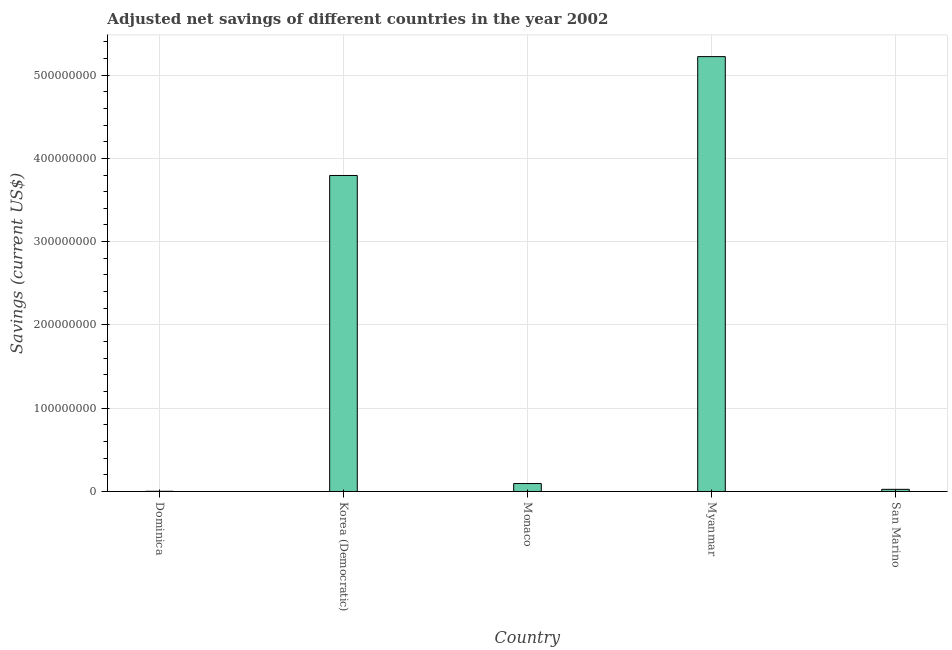What is the title of the graph?
Your answer should be compact. Adjusted net savings of different countries in the year 2002. What is the label or title of the Y-axis?
Your answer should be compact. Savings (current US$). What is the adjusted net savings in Myanmar?
Offer a terse response. 5.22e+08. Across all countries, what is the maximum adjusted net savings?
Your answer should be very brief. 5.22e+08. Across all countries, what is the minimum adjusted net savings?
Your answer should be compact. 2.14e+05. In which country was the adjusted net savings maximum?
Keep it short and to the point. Myanmar. In which country was the adjusted net savings minimum?
Offer a very short reply. Dominica. What is the sum of the adjusted net savings?
Keep it short and to the point. 9.14e+08. What is the difference between the adjusted net savings in Dominica and San Marino?
Ensure brevity in your answer.  -2.35e+06. What is the average adjusted net savings per country?
Provide a short and direct response. 1.83e+08. What is the median adjusted net savings?
Your answer should be compact. 9.52e+06. In how many countries, is the adjusted net savings greater than 360000000 US$?
Offer a very short reply. 2. What is the ratio of the adjusted net savings in Korea (Democratic) to that in Myanmar?
Give a very brief answer. 0.73. Is the difference between the adjusted net savings in Korea (Democratic) and Monaco greater than the difference between any two countries?
Give a very brief answer. No. What is the difference between the highest and the second highest adjusted net savings?
Keep it short and to the point. 1.43e+08. Is the sum of the adjusted net savings in Korea (Democratic) and Myanmar greater than the maximum adjusted net savings across all countries?
Ensure brevity in your answer.  Yes. What is the difference between the highest and the lowest adjusted net savings?
Offer a terse response. 5.22e+08. Are all the bars in the graph horizontal?
Give a very brief answer. No. How many countries are there in the graph?
Provide a short and direct response. 5. What is the Savings (current US$) of Dominica?
Offer a very short reply. 2.14e+05. What is the Savings (current US$) of Korea (Democratic)?
Give a very brief answer. 3.79e+08. What is the Savings (current US$) in Monaco?
Give a very brief answer. 9.52e+06. What is the Savings (current US$) of Myanmar?
Offer a very short reply. 5.22e+08. What is the Savings (current US$) of San Marino?
Your answer should be very brief. 2.57e+06. What is the difference between the Savings (current US$) in Dominica and Korea (Democratic)?
Make the answer very short. -3.79e+08. What is the difference between the Savings (current US$) in Dominica and Monaco?
Make the answer very short. -9.31e+06. What is the difference between the Savings (current US$) in Dominica and Myanmar?
Give a very brief answer. -5.22e+08. What is the difference between the Savings (current US$) in Dominica and San Marino?
Your response must be concise. -2.35e+06. What is the difference between the Savings (current US$) in Korea (Democratic) and Monaco?
Ensure brevity in your answer.  3.70e+08. What is the difference between the Savings (current US$) in Korea (Democratic) and Myanmar?
Provide a short and direct response. -1.43e+08. What is the difference between the Savings (current US$) in Korea (Democratic) and San Marino?
Offer a very short reply. 3.77e+08. What is the difference between the Savings (current US$) in Monaco and Myanmar?
Offer a terse response. -5.13e+08. What is the difference between the Savings (current US$) in Monaco and San Marino?
Offer a terse response. 6.96e+06. What is the difference between the Savings (current US$) in Myanmar and San Marino?
Keep it short and to the point. 5.20e+08. What is the ratio of the Savings (current US$) in Dominica to that in Korea (Democratic)?
Offer a very short reply. 0. What is the ratio of the Savings (current US$) in Dominica to that in Monaco?
Your answer should be very brief. 0.02. What is the ratio of the Savings (current US$) in Dominica to that in San Marino?
Ensure brevity in your answer.  0.08. What is the ratio of the Savings (current US$) in Korea (Democratic) to that in Monaco?
Provide a succinct answer. 39.84. What is the ratio of the Savings (current US$) in Korea (Democratic) to that in Myanmar?
Your answer should be compact. 0.73. What is the ratio of the Savings (current US$) in Korea (Democratic) to that in San Marino?
Your response must be concise. 147.76. What is the ratio of the Savings (current US$) in Monaco to that in Myanmar?
Provide a short and direct response. 0.02. What is the ratio of the Savings (current US$) in Monaco to that in San Marino?
Provide a succinct answer. 3.71. What is the ratio of the Savings (current US$) in Myanmar to that in San Marino?
Your answer should be very brief. 203.34. 